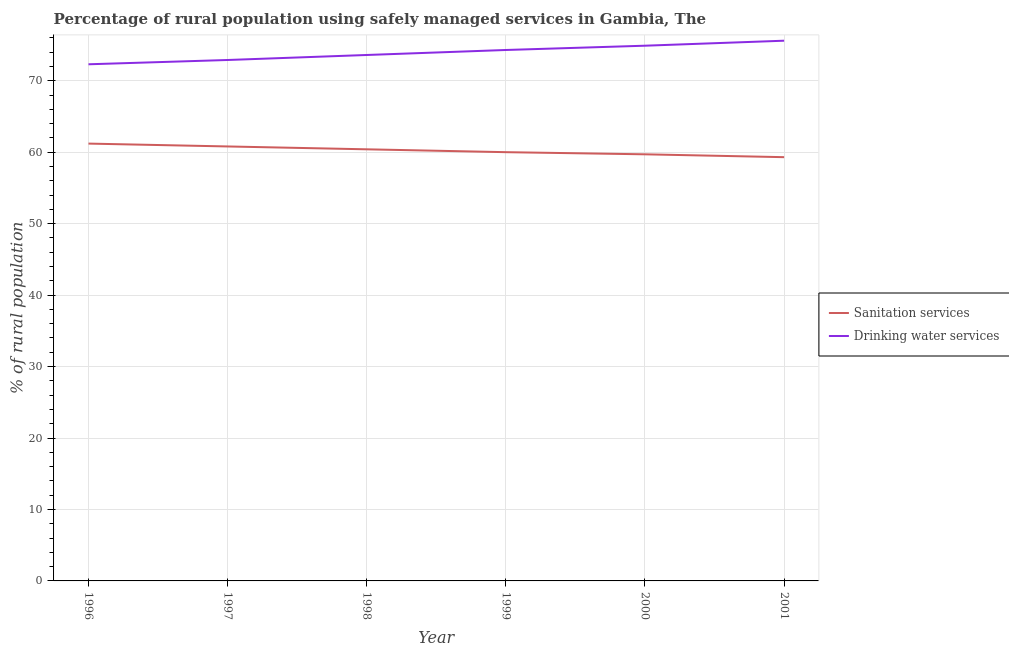How many different coloured lines are there?
Make the answer very short. 2. Is the number of lines equal to the number of legend labels?
Offer a very short reply. Yes. Across all years, what is the maximum percentage of rural population who used sanitation services?
Give a very brief answer. 61.2. Across all years, what is the minimum percentage of rural population who used sanitation services?
Your answer should be compact. 59.3. In which year was the percentage of rural population who used sanitation services maximum?
Your answer should be compact. 1996. What is the total percentage of rural population who used drinking water services in the graph?
Provide a short and direct response. 443.6. What is the difference between the percentage of rural population who used sanitation services in 2000 and the percentage of rural population who used drinking water services in 2001?
Ensure brevity in your answer.  -15.9. What is the average percentage of rural population who used sanitation services per year?
Give a very brief answer. 60.23. In the year 1997, what is the difference between the percentage of rural population who used sanitation services and percentage of rural population who used drinking water services?
Provide a short and direct response. -12.1. In how many years, is the percentage of rural population who used sanitation services greater than 28 %?
Offer a terse response. 6. What is the ratio of the percentage of rural population who used drinking water services in 1998 to that in 2001?
Make the answer very short. 0.97. Is the difference between the percentage of rural population who used sanitation services in 1999 and 2001 greater than the difference between the percentage of rural population who used drinking water services in 1999 and 2001?
Make the answer very short. Yes. What is the difference between the highest and the second highest percentage of rural population who used drinking water services?
Give a very brief answer. 0.7. What is the difference between the highest and the lowest percentage of rural population who used sanitation services?
Your response must be concise. 1.9. In how many years, is the percentage of rural population who used drinking water services greater than the average percentage of rural population who used drinking water services taken over all years?
Offer a very short reply. 3. Is the percentage of rural population who used sanitation services strictly greater than the percentage of rural population who used drinking water services over the years?
Your response must be concise. No. How many lines are there?
Make the answer very short. 2. How many years are there in the graph?
Keep it short and to the point. 6. What is the difference between two consecutive major ticks on the Y-axis?
Provide a succinct answer. 10. Does the graph contain any zero values?
Make the answer very short. No. Does the graph contain grids?
Your response must be concise. Yes. How are the legend labels stacked?
Ensure brevity in your answer.  Vertical. What is the title of the graph?
Make the answer very short. Percentage of rural population using safely managed services in Gambia, The. What is the label or title of the X-axis?
Your answer should be compact. Year. What is the label or title of the Y-axis?
Give a very brief answer. % of rural population. What is the % of rural population in Sanitation services in 1996?
Offer a terse response. 61.2. What is the % of rural population of Drinking water services in 1996?
Keep it short and to the point. 72.3. What is the % of rural population in Sanitation services in 1997?
Your response must be concise. 60.8. What is the % of rural population of Drinking water services in 1997?
Offer a very short reply. 72.9. What is the % of rural population of Sanitation services in 1998?
Provide a short and direct response. 60.4. What is the % of rural population in Drinking water services in 1998?
Offer a terse response. 73.6. What is the % of rural population in Drinking water services in 1999?
Ensure brevity in your answer.  74.3. What is the % of rural population of Sanitation services in 2000?
Keep it short and to the point. 59.7. What is the % of rural population of Drinking water services in 2000?
Provide a succinct answer. 74.9. What is the % of rural population of Sanitation services in 2001?
Provide a short and direct response. 59.3. What is the % of rural population of Drinking water services in 2001?
Offer a terse response. 75.6. Across all years, what is the maximum % of rural population in Sanitation services?
Keep it short and to the point. 61.2. Across all years, what is the maximum % of rural population of Drinking water services?
Your response must be concise. 75.6. Across all years, what is the minimum % of rural population of Sanitation services?
Offer a terse response. 59.3. Across all years, what is the minimum % of rural population of Drinking water services?
Provide a succinct answer. 72.3. What is the total % of rural population in Sanitation services in the graph?
Your answer should be compact. 361.4. What is the total % of rural population in Drinking water services in the graph?
Give a very brief answer. 443.6. What is the difference between the % of rural population of Sanitation services in 1996 and that in 1998?
Provide a short and direct response. 0.8. What is the difference between the % of rural population in Drinking water services in 1996 and that in 1998?
Your answer should be very brief. -1.3. What is the difference between the % of rural population in Sanitation services in 1996 and that in 1999?
Keep it short and to the point. 1.2. What is the difference between the % of rural population in Drinking water services in 1996 and that in 1999?
Your answer should be very brief. -2. What is the difference between the % of rural population of Drinking water services in 1996 and that in 2000?
Give a very brief answer. -2.6. What is the difference between the % of rural population in Drinking water services in 1996 and that in 2001?
Provide a succinct answer. -3.3. What is the difference between the % of rural population of Sanitation services in 1997 and that in 1998?
Keep it short and to the point. 0.4. What is the difference between the % of rural population in Drinking water services in 1997 and that in 1998?
Offer a very short reply. -0.7. What is the difference between the % of rural population in Sanitation services in 1997 and that in 1999?
Keep it short and to the point. 0.8. What is the difference between the % of rural population of Sanitation services in 1997 and that in 2000?
Give a very brief answer. 1.1. What is the difference between the % of rural population in Drinking water services in 1997 and that in 2000?
Your answer should be very brief. -2. What is the difference between the % of rural population of Sanitation services in 1997 and that in 2001?
Keep it short and to the point. 1.5. What is the difference between the % of rural population of Drinking water services in 1997 and that in 2001?
Your response must be concise. -2.7. What is the difference between the % of rural population in Sanitation services in 1998 and that in 1999?
Make the answer very short. 0.4. What is the difference between the % of rural population in Drinking water services in 1998 and that in 1999?
Give a very brief answer. -0.7. What is the difference between the % of rural population in Drinking water services in 1998 and that in 2000?
Provide a succinct answer. -1.3. What is the difference between the % of rural population in Drinking water services in 1998 and that in 2001?
Keep it short and to the point. -2. What is the difference between the % of rural population of Sanitation services in 1999 and that in 2000?
Your answer should be very brief. 0.3. What is the difference between the % of rural population in Drinking water services in 1999 and that in 2000?
Offer a terse response. -0.6. What is the difference between the % of rural population of Drinking water services in 1999 and that in 2001?
Give a very brief answer. -1.3. What is the difference between the % of rural population in Sanitation services in 1996 and the % of rural population in Drinking water services in 1997?
Give a very brief answer. -11.7. What is the difference between the % of rural population of Sanitation services in 1996 and the % of rural population of Drinking water services in 1998?
Make the answer very short. -12.4. What is the difference between the % of rural population in Sanitation services in 1996 and the % of rural population in Drinking water services in 1999?
Your answer should be compact. -13.1. What is the difference between the % of rural population in Sanitation services in 1996 and the % of rural population in Drinking water services in 2000?
Your answer should be compact. -13.7. What is the difference between the % of rural population in Sanitation services in 1996 and the % of rural population in Drinking water services in 2001?
Provide a succinct answer. -14.4. What is the difference between the % of rural population in Sanitation services in 1997 and the % of rural population in Drinking water services in 1999?
Ensure brevity in your answer.  -13.5. What is the difference between the % of rural population in Sanitation services in 1997 and the % of rural population in Drinking water services in 2000?
Provide a short and direct response. -14.1. What is the difference between the % of rural population of Sanitation services in 1997 and the % of rural population of Drinking water services in 2001?
Provide a succinct answer. -14.8. What is the difference between the % of rural population in Sanitation services in 1998 and the % of rural population in Drinking water services in 1999?
Your answer should be very brief. -13.9. What is the difference between the % of rural population of Sanitation services in 1998 and the % of rural population of Drinking water services in 2001?
Ensure brevity in your answer.  -15.2. What is the difference between the % of rural population in Sanitation services in 1999 and the % of rural population in Drinking water services in 2000?
Ensure brevity in your answer.  -14.9. What is the difference between the % of rural population in Sanitation services in 1999 and the % of rural population in Drinking water services in 2001?
Offer a terse response. -15.6. What is the difference between the % of rural population of Sanitation services in 2000 and the % of rural population of Drinking water services in 2001?
Your answer should be very brief. -15.9. What is the average % of rural population of Sanitation services per year?
Make the answer very short. 60.23. What is the average % of rural population of Drinking water services per year?
Offer a terse response. 73.93. In the year 1997, what is the difference between the % of rural population in Sanitation services and % of rural population in Drinking water services?
Offer a terse response. -12.1. In the year 1999, what is the difference between the % of rural population in Sanitation services and % of rural population in Drinking water services?
Your answer should be very brief. -14.3. In the year 2000, what is the difference between the % of rural population in Sanitation services and % of rural population in Drinking water services?
Keep it short and to the point. -15.2. In the year 2001, what is the difference between the % of rural population in Sanitation services and % of rural population in Drinking water services?
Ensure brevity in your answer.  -16.3. What is the ratio of the % of rural population of Sanitation services in 1996 to that in 1997?
Your answer should be very brief. 1.01. What is the ratio of the % of rural population of Drinking water services in 1996 to that in 1997?
Offer a terse response. 0.99. What is the ratio of the % of rural population in Sanitation services in 1996 to that in 1998?
Make the answer very short. 1.01. What is the ratio of the % of rural population of Drinking water services in 1996 to that in 1998?
Your response must be concise. 0.98. What is the ratio of the % of rural population of Drinking water services in 1996 to that in 1999?
Keep it short and to the point. 0.97. What is the ratio of the % of rural population of Sanitation services in 1996 to that in 2000?
Your answer should be compact. 1.03. What is the ratio of the % of rural population in Drinking water services in 1996 to that in 2000?
Ensure brevity in your answer.  0.97. What is the ratio of the % of rural population in Sanitation services in 1996 to that in 2001?
Keep it short and to the point. 1.03. What is the ratio of the % of rural population in Drinking water services in 1996 to that in 2001?
Your answer should be very brief. 0.96. What is the ratio of the % of rural population in Sanitation services in 1997 to that in 1998?
Offer a very short reply. 1.01. What is the ratio of the % of rural population of Drinking water services in 1997 to that in 1998?
Your response must be concise. 0.99. What is the ratio of the % of rural population in Sanitation services in 1997 to that in 1999?
Offer a terse response. 1.01. What is the ratio of the % of rural population in Drinking water services in 1997 to that in 1999?
Make the answer very short. 0.98. What is the ratio of the % of rural population in Sanitation services in 1997 to that in 2000?
Provide a succinct answer. 1.02. What is the ratio of the % of rural population in Drinking water services in 1997 to that in 2000?
Ensure brevity in your answer.  0.97. What is the ratio of the % of rural population in Sanitation services in 1997 to that in 2001?
Give a very brief answer. 1.03. What is the ratio of the % of rural population of Drinking water services in 1998 to that in 1999?
Your answer should be very brief. 0.99. What is the ratio of the % of rural population of Sanitation services in 1998 to that in 2000?
Keep it short and to the point. 1.01. What is the ratio of the % of rural population of Drinking water services in 1998 to that in 2000?
Your answer should be compact. 0.98. What is the ratio of the % of rural population in Sanitation services in 1998 to that in 2001?
Make the answer very short. 1.02. What is the ratio of the % of rural population of Drinking water services in 1998 to that in 2001?
Keep it short and to the point. 0.97. What is the ratio of the % of rural population in Sanitation services in 1999 to that in 2001?
Your response must be concise. 1.01. What is the ratio of the % of rural population in Drinking water services in 1999 to that in 2001?
Your answer should be very brief. 0.98. What is the ratio of the % of rural population in Sanitation services in 2000 to that in 2001?
Provide a succinct answer. 1.01. What is the difference between the highest and the second highest % of rural population in Drinking water services?
Keep it short and to the point. 0.7. 